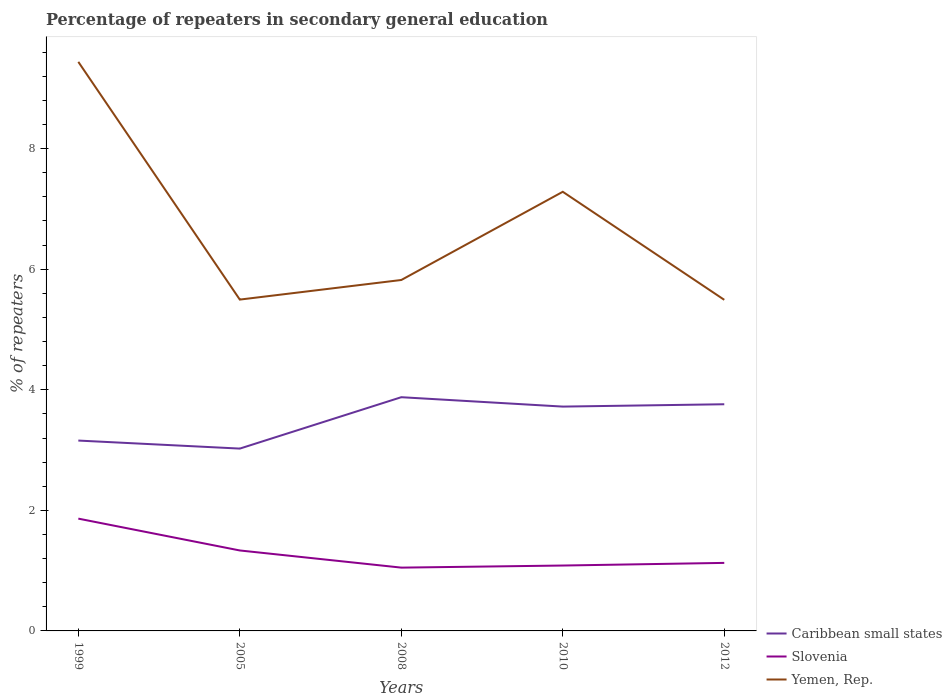Is the number of lines equal to the number of legend labels?
Your answer should be compact. Yes. Across all years, what is the maximum percentage of repeaters in secondary general education in Slovenia?
Make the answer very short. 1.05. In which year was the percentage of repeaters in secondary general education in Slovenia maximum?
Offer a terse response. 2008. What is the total percentage of repeaters in secondary general education in Yemen, Rep. in the graph?
Your response must be concise. -0.33. What is the difference between the highest and the second highest percentage of repeaters in secondary general education in Slovenia?
Offer a very short reply. 0.81. Is the percentage of repeaters in secondary general education in Yemen, Rep. strictly greater than the percentage of repeaters in secondary general education in Slovenia over the years?
Give a very brief answer. No. How many years are there in the graph?
Offer a terse response. 5. Are the values on the major ticks of Y-axis written in scientific E-notation?
Ensure brevity in your answer.  No. Does the graph contain any zero values?
Offer a terse response. No. Where does the legend appear in the graph?
Offer a very short reply. Bottom right. How many legend labels are there?
Offer a very short reply. 3. How are the legend labels stacked?
Give a very brief answer. Vertical. What is the title of the graph?
Offer a very short reply. Percentage of repeaters in secondary general education. What is the label or title of the Y-axis?
Offer a terse response. % of repeaters. What is the % of repeaters of Caribbean small states in 1999?
Your answer should be very brief. 3.16. What is the % of repeaters in Slovenia in 1999?
Provide a succinct answer. 1.86. What is the % of repeaters in Yemen, Rep. in 1999?
Give a very brief answer. 9.44. What is the % of repeaters in Caribbean small states in 2005?
Give a very brief answer. 3.02. What is the % of repeaters in Slovenia in 2005?
Your answer should be compact. 1.33. What is the % of repeaters of Yemen, Rep. in 2005?
Ensure brevity in your answer.  5.5. What is the % of repeaters in Caribbean small states in 2008?
Make the answer very short. 3.88. What is the % of repeaters of Slovenia in 2008?
Provide a short and direct response. 1.05. What is the % of repeaters of Yemen, Rep. in 2008?
Offer a very short reply. 5.82. What is the % of repeaters of Caribbean small states in 2010?
Your answer should be very brief. 3.72. What is the % of repeaters of Slovenia in 2010?
Give a very brief answer. 1.08. What is the % of repeaters of Yemen, Rep. in 2010?
Provide a short and direct response. 7.28. What is the % of repeaters in Caribbean small states in 2012?
Your answer should be compact. 3.76. What is the % of repeaters in Slovenia in 2012?
Make the answer very short. 1.13. What is the % of repeaters in Yemen, Rep. in 2012?
Provide a succinct answer. 5.49. Across all years, what is the maximum % of repeaters of Caribbean small states?
Provide a succinct answer. 3.88. Across all years, what is the maximum % of repeaters in Slovenia?
Offer a terse response. 1.86. Across all years, what is the maximum % of repeaters in Yemen, Rep.?
Ensure brevity in your answer.  9.44. Across all years, what is the minimum % of repeaters in Caribbean small states?
Your response must be concise. 3.02. Across all years, what is the minimum % of repeaters of Slovenia?
Your response must be concise. 1.05. Across all years, what is the minimum % of repeaters of Yemen, Rep.?
Make the answer very short. 5.49. What is the total % of repeaters of Caribbean small states in the graph?
Ensure brevity in your answer.  17.54. What is the total % of repeaters in Slovenia in the graph?
Make the answer very short. 6.46. What is the total % of repeaters in Yemen, Rep. in the graph?
Make the answer very short. 33.53. What is the difference between the % of repeaters in Caribbean small states in 1999 and that in 2005?
Offer a terse response. 0.13. What is the difference between the % of repeaters of Slovenia in 1999 and that in 2005?
Your answer should be compact. 0.53. What is the difference between the % of repeaters in Yemen, Rep. in 1999 and that in 2005?
Give a very brief answer. 3.94. What is the difference between the % of repeaters of Caribbean small states in 1999 and that in 2008?
Offer a terse response. -0.72. What is the difference between the % of repeaters in Slovenia in 1999 and that in 2008?
Give a very brief answer. 0.81. What is the difference between the % of repeaters of Yemen, Rep. in 1999 and that in 2008?
Keep it short and to the point. 3.62. What is the difference between the % of repeaters in Caribbean small states in 1999 and that in 2010?
Offer a very short reply. -0.56. What is the difference between the % of repeaters in Slovenia in 1999 and that in 2010?
Keep it short and to the point. 0.78. What is the difference between the % of repeaters in Yemen, Rep. in 1999 and that in 2010?
Give a very brief answer. 2.16. What is the difference between the % of repeaters of Caribbean small states in 1999 and that in 2012?
Your answer should be compact. -0.6. What is the difference between the % of repeaters in Slovenia in 1999 and that in 2012?
Your answer should be compact. 0.73. What is the difference between the % of repeaters in Yemen, Rep. in 1999 and that in 2012?
Give a very brief answer. 3.95. What is the difference between the % of repeaters in Caribbean small states in 2005 and that in 2008?
Ensure brevity in your answer.  -0.85. What is the difference between the % of repeaters in Slovenia in 2005 and that in 2008?
Provide a succinct answer. 0.28. What is the difference between the % of repeaters of Yemen, Rep. in 2005 and that in 2008?
Your answer should be compact. -0.33. What is the difference between the % of repeaters in Caribbean small states in 2005 and that in 2010?
Provide a short and direct response. -0.7. What is the difference between the % of repeaters of Slovenia in 2005 and that in 2010?
Give a very brief answer. 0.25. What is the difference between the % of repeaters of Yemen, Rep. in 2005 and that in 2010?
Your answer should be compact. -1.79. What is the difference between the % of repeaters of Caribbean small states in 2005 and that in 2012?
Offer a very short reply. -0.74. What is the difference between the % of repeaters of Slovenia in 2005 and that in 2012?
Make the answer very short. 0.21. What is the difference between the % of repeaters of Yemen, Rep. in 2005 and that in 2012?
Make the answer very short. 0. What is the difference between the % of repeaters of Caribbean small states in 2008 and that in 2010?
Keep it short and to the point. 0.16. What is the difference between the % of repeaters in Slovenia in 2008 and that in 2010?
Offer a terse response. -0.03. What is the difference between the % of repeaters of Yemen, Rep. in 2008 and that in 2010?
Offer a terse response. -1.46. What is the difference between the % of repeaters of Caribbean small states in 2008 and that in 2012?
Give a very brief answer. 0.12. What is the difference between the % of repeaters in Slovenia in 2008 and that in 2012?
Provide a short and direct response. -0.08. What is the difference between the % of repeaters of Yemen, Rep. in 2008 and that in 2012?
Keep it short and to the point. 0.33. What is the difference between the % of repeaters in Caribbean small states in 2010 and that in 2012?
Your answer should be compact. -0.04. What is the difference between the % of repeaters in Slovenia in 2010 and that in 2012?
Make the answer very short. -0.04. What is the difference between the % of repeaters in Yemen, Rep. in 2010 and that in 2012?
Your answer should be compact. 1.79. What is the difference between the % of repeaters in Caribbean small states in 1999 and the % of repeaters in Slovenia in 2005?
Your answer should be very brief. 1.82. What is the difference between the % of repeaters in Caribbean small states in 1999 and the % of repeaters in Yemen, Rep. in 2005?
Ensure brevity in your answer.  -2.34. What is the difference between the % of repeaters of Slovenia in 1999 and the % of repeaters of Yemen, Rep. in 2005?
Provide a succinct answer. -3.63. What is the difference between the % of repeaters of Caribbean small states in 1999 and the % of repeaters of Slovenia in 2008?
Make the answer very short. 2.11. What is the difference between the % of repeaters in Caribbean small states in 1999 and the % of repeaters in Yemen, Rep. in 2008?
Offer a terse response. -2.66. What is the difference between the % of repeaters in Slovenia in 1999 and the % of repeaters in Yemen, Rep. in 2008?
Your answer should be very brief. -3.96. What is the difference between the % of repeaters of Caribbean small states in 1999 and the % of repeaters of Slovenia in 2010?
Keep it short and to the point. 2.07. What is the difference between the % of repeaters of Caribbean small states in 1999 and the % of repeaters of Yemen, Rep. in 2010?
Offer a terse response. -4.13. What is the difference between the % of repeaters of Slovenia in 1999 and the % of repeaters of Yemen, Rep. in 2010?
Keep it short and to the point. -5.42. What is the difference between the % of repeaters of Caribbean small states in 1999 and the % of repeaters of Slovenia in 2012?
Your answer should be very brief. 2.03. What is the difference between the % of repeaters of Caribbean small states in 1999 and the % of repeaters of Yemen, Rep. in 2012?
Keep it short and to the point. -2.33. What is the difference between the % of repeaters of Slovenia in 1999 and the % of repeaters of Yemen, Rep. in 2012?
Your answer should be compact. -3.63. What is the difference between the % of repeaters of Caribbean small states in 2005 and the % of repeaters of Slovenia in 2008?
Your answer should be very brief. 1.97. What is the difference between the % of repeaters in Caribbean small states in 2005 and the % of repeaters in Yemen, Rep. in 2008?
Offer a very short reply. -2.8. What is the difference between the % of repeaters of Slovenia in 2005 and the % of repeaters of Yemen, Rep. in 2008?
Your answer should be very brief. -4.49. What is the difference between the % of repeaters in Caribbean small states in 2005 and the % of repeaters in Slovenia in 2010?
Ensure brevity in your answer.  1.94. What is the difference between the % of repeaters of Caribbean small states in 2005 and the % of repeaters of Yemen, Rep. in 2010?
Your answer should be compact. -4.26. What is the difference between the % of repeaters of Slovenia in 2005 and the % of repeaters of Yemen, Rep. in 2010?
Offer a terse response. -5.95. What is the difference between the % of repeaters of Caribbean small states in 2005 and the % of repeaters of Slovenia in 2012?
Keep it short and to the point. 1.9. What is the difference between the % of repeaters of Caribbean small states in 2005 and the % of repeaters of Yemen, Rep. in 2012?
Your response must be concise. -2.47. What is the difference between the % of repeaters of Slovenia in 2005 and the % of repeaters of Yemen, Rep. in 2012?
Provide a short and direct response. -4.16. What is the difference between the % of repeaters of Caribbean small states in 2008 and the % of repeaters of Slovenia in 2010?
Keep it short and to the point. 2.79. What is the difference between the % of repeaters in Caribbean small states in 2008 and the % of repeaters in Yemen, Rep. in 2010?
Offer a very short reply. -3.41. What is the difference between the % of repeaters of Slovenia in 2008 and the % of repeaters of Yemen, Rep. in 2010?
Make the answer very short. -6.23. What is the difference between the % of repeaters in Caribbean small states in 2008 and the % of repeaters in Slovenia in 2012?
Provide a short and direct response. 2.75. What is the difference between the % of repeaters in Caribbean small states in 2008 and the % of repeaters in Yemen, Rep. in 2012?
Make the answer very short. -1.62. What is the difference between the % of repeaters of Slovenia in 2008 and the % of repeaters of Yemen, Rep. in 2012?
Keep it short and to the point. -4.44. What is the difference between the % of repeaters in Caribbean small states in 2010 and the % of repeaters in Slovenia in 2012?
Keep it short and to the point. 2.59. What is the difference between the % of repeaters of Caribbean small states in 2010 and the % of repeaters of Yemen, Rep. in 2012?
Offer a terse response. -1.77. What is the difference between the % of repeaters in Slovenia in 2010 and the % of repeaters in Yemen, Rep. in 2012?
Offer a very short reply. -4.41. What is the average % of repeaters of Caribbean small states per year?
Your answer should be compact. 3.51. What is the average % of repeaters of Slovenia per year?
Give a very brief answer. 1.29. What is the average % of repeaters in Yemen, Rep. per year?
Offer a very short reply. 6.71. In the year 1999, what is the difference between the % of repeaters in Caribbean small states and % of repeaters in Slovenia?
Your answer should be compact. 1.29. In the year 1999, what is the difference between the % of repeaters in Caribbean small states and % of repeaters in Yemen, Rep.?
Your answer should be very brief. -6.28. In the year 1999, what is the difference between the % of repeaters in Slovenia and % of repeaters in Yemen, Rep.?
Give a very brief answer. -7.58. In the year 2005, what is the difference between the % of repeaters in Caribbean small states and % of repeaters in Slovenia?
Keep it short and to the point. 1.69. In the year 2005, what is the difference between the % of repeaters of Caribbean small states and % of repeaters of Yemen, Rep.?
Offer a terse response. -2.47. In the year 2005, what is the difference between the % of repeaters in Slovenia and % of repeaters in Yemen, Rep.?
Your answer should be compact. -4.16. In the year 2008, what is the difference between the % of repeaters of Caribbean small states and % of repeaters of Slovenia?
Your answer should be very brief. 2.83. In the year 2008, what is the difference between the % of repeaters in Caribbean small states and % of repeaters in Yemen, Rep.?
Make the answer very short. -1.94. In the year 2008, what is the difference between the % of repeaters in Slovenia and % of repeaters in Yemen, Rep.?
Your answer should be compact. -4.77. In the year 2010, what is the difference between the % of repeaters of Caribbean small states and % of repeaters of Slovenia?
Keep it short and to the point. 2.64. In the year 2010, what is the difference between the % of repeaters in Caribbean small states and % of repeaters in Yemen, Rep.?
Provide a short and direct response. -3.56. In the year 2010, what is the difference between the % of repeaters of Slovenia and % of repeaters of Yemen, Rep.?
Provide a short and direct response. -6.2. In the year 2012, what is the difference between the % of repeaters in Caribbean small states and % of repeaters in Slovenia?
Ensure brevity in your answer.  2.63. In the year 2012, what is the difference between the % of repeaters of Caribbean small states and % of repeaters of Yemen, Rep.?
Offer a very short reply. -1.73. In the year 2012, what is the difference between the % of repeaters of Slovenia and % of repeaters of Yemen, Rep.?
Provide a succinct answer. -4.36. What is the ratio of the % of repeaters in Caribbean small states in 1999 to that in 2005?
Your answer should be compact. 1.04. What is the ratio of the % of repeaters of Slovenia in 1999 to that in 2005?
Give a very brief answer. 1.4. What is the ratio of the % of repeaters in Yemen, Rep. in 1999 to that in 2005?
Make the answer very short. 1.72. What is the ratio of the % of repeaters of Caribbean small states in 1999 to that in 2008?
Keep it short and to the point. 0.81. What is the ratio of the % of repeaters of Slovenia in 1999 to that in 2008?
Your answer should be compact. 1.77. What is the ratio of the % of repeaters of Yemen, Rep. in 1999 to that in 2008?
Offer a very short reply. 1.62. What is the ratio of the % of repeaters of Caribbean small states in 1999 to that in 2010?
Provide a succinct answer. 0.85. What is the ratio of the % of repeaters in Slovenia in 1999 to that in 2010?
Ensure brevity in your answer.  1.72. What is the ratio of the % of repeaters in Yemen, Rep. in 1999 to that in 2010?
Provide a short and direct response. 1.3. What is the ratio of the % of repeaters in Caribbean small states in 1999 to that in 2012?
Your answer should be compact. 0.84. What is the ratio of the % of repeaters in Slovenia in 1999 to that in 2012?
Your response must be concise. 1.65. What is the ratio of the % of repeaters in Yemen, Rep. in 1999 to that in 2012?
Provide a succinct answer. 1.72. What is the ratio of the % of repeaters of Caribbean small states in 2005 to that in 2008?
Keep it short and to the point. 0.78. What is the ratio of the % of repeaters in Slovenia in 2005 to that in 2008?
Ensure brevity in your answer.  1.27. What is the ratio of the % of repeaters in Yemen, Rep. in 2005 to that in 2008?
Your answer should be compact. 0.94. What is the ratio of the % of repeaters in Caribbean small states in 2005 to that in 2010?
Make the answer very short. 0.81. What is the ratio of the % of repeaters in Slovenia in 2005 to that in 2010?
Provide a succinct answer. 1.23. What is the ratio of the % of repeaters in Yemen, Rep. in 2005 to that in 2010?
Give a very brief answer. 0.75. What is the ratio of the % of repeaters of Caribbean small states in 2005 to that in 2012?
Make the answer very short. 0.8. What is the ratio of the % of repeaters of Slovenia in 2005 to that in 2012?
Your answer should be very brief. 1.18. What is the ratio of the % of repeaters in Yemen, Rep. in 2005 to that in 2012?
Provide a succinct answer. 1. What is the ratio of the % of repeaters in Caribbean small states in 2008 to that in 2010?
Provide a succinct answer. 1.04. What is the ratio of the % of repeaters of Slovenia in 2008 to that in 2010?
Provide a short and direct response. 0.97. What is the ratio of the % of repeaters in Yemen, Rep. in 2008 to that in 2010?
Your answer should be very brief. 0.8. What is the ratio of the % of repeaters of Caribbean small states in 2008 to that in 2012?
Keep it short and to the point. 1.03. What is the ratio of the % of repeaters in Slovenia in 2008 to that in 2012?
Your response must be concise. 0.93. What is the ratio of the % of repeaters in Yemen, Rep. in 2008 to that in 2012?
Provide a short and direct response. 1.06. What is the ratio of the % of repeaters of Caribbean small states in 2010 to that in 2012?
Give a very brief answer. 0.99. What is the ratio of the % of repeaters in Slovenia in 2010 to that in 2012?
Your response must be concise. 0.96. What is the ratio of the % of repeaters of Yemen, Rep. in 2010 to that in 2012?
Your response must be concise. 1.33. What is the difference between the highest and the second highest % of repeaters of Caribbean small states?
Give a very brief answer. 0.12. What is the difference between the highest and the second highest % of repeaters of Slovenia?
Ensure brevity in your answer.  0.53. What is the difference between the highest and the second highest % of repeaters in Yemen, Rep.?
Keep it short and to the point. 2.16. What is the difference between the highest and the lowest % of repeaters in Caribbean small states?
Keep it short and to the point. 0.85. What is the difference between the highest and the lowest % of repeaters in Slovenia?
Provide a succinct answer. 0.81. What is the difference between the highest and the lowest % of repeaters in Yemen, Rep.?
Ensure brevity in your answer.  3.95. 